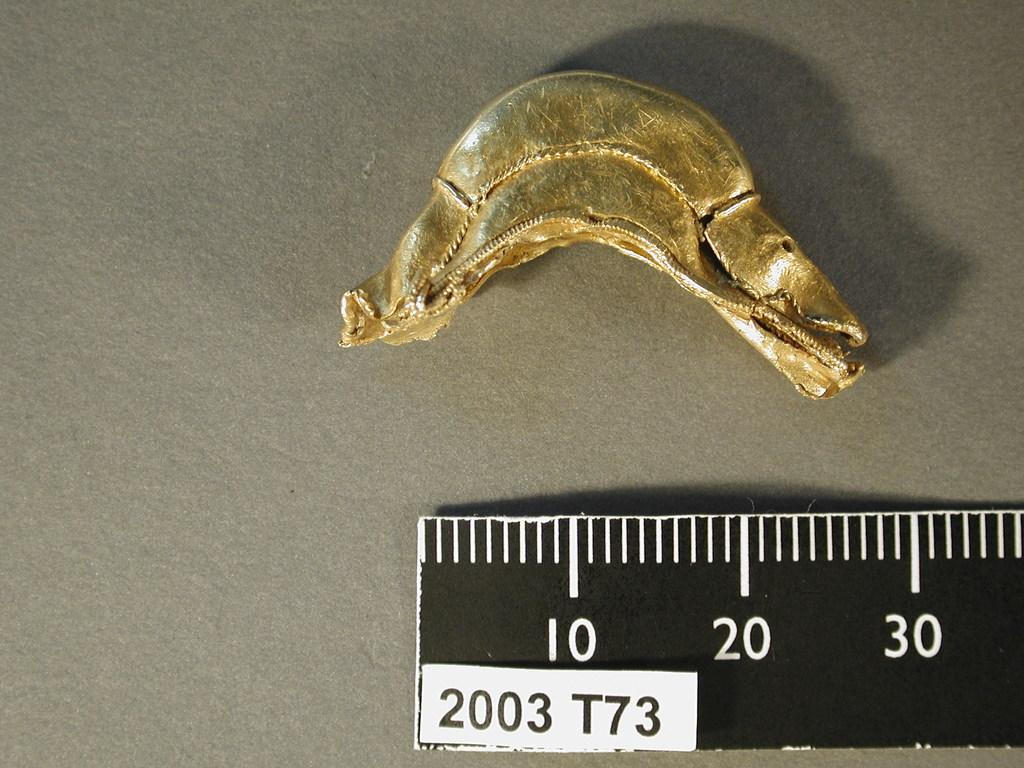<image>
Describe the image concisely. Black ruler that says 2003 T73 measuring a gold object. 